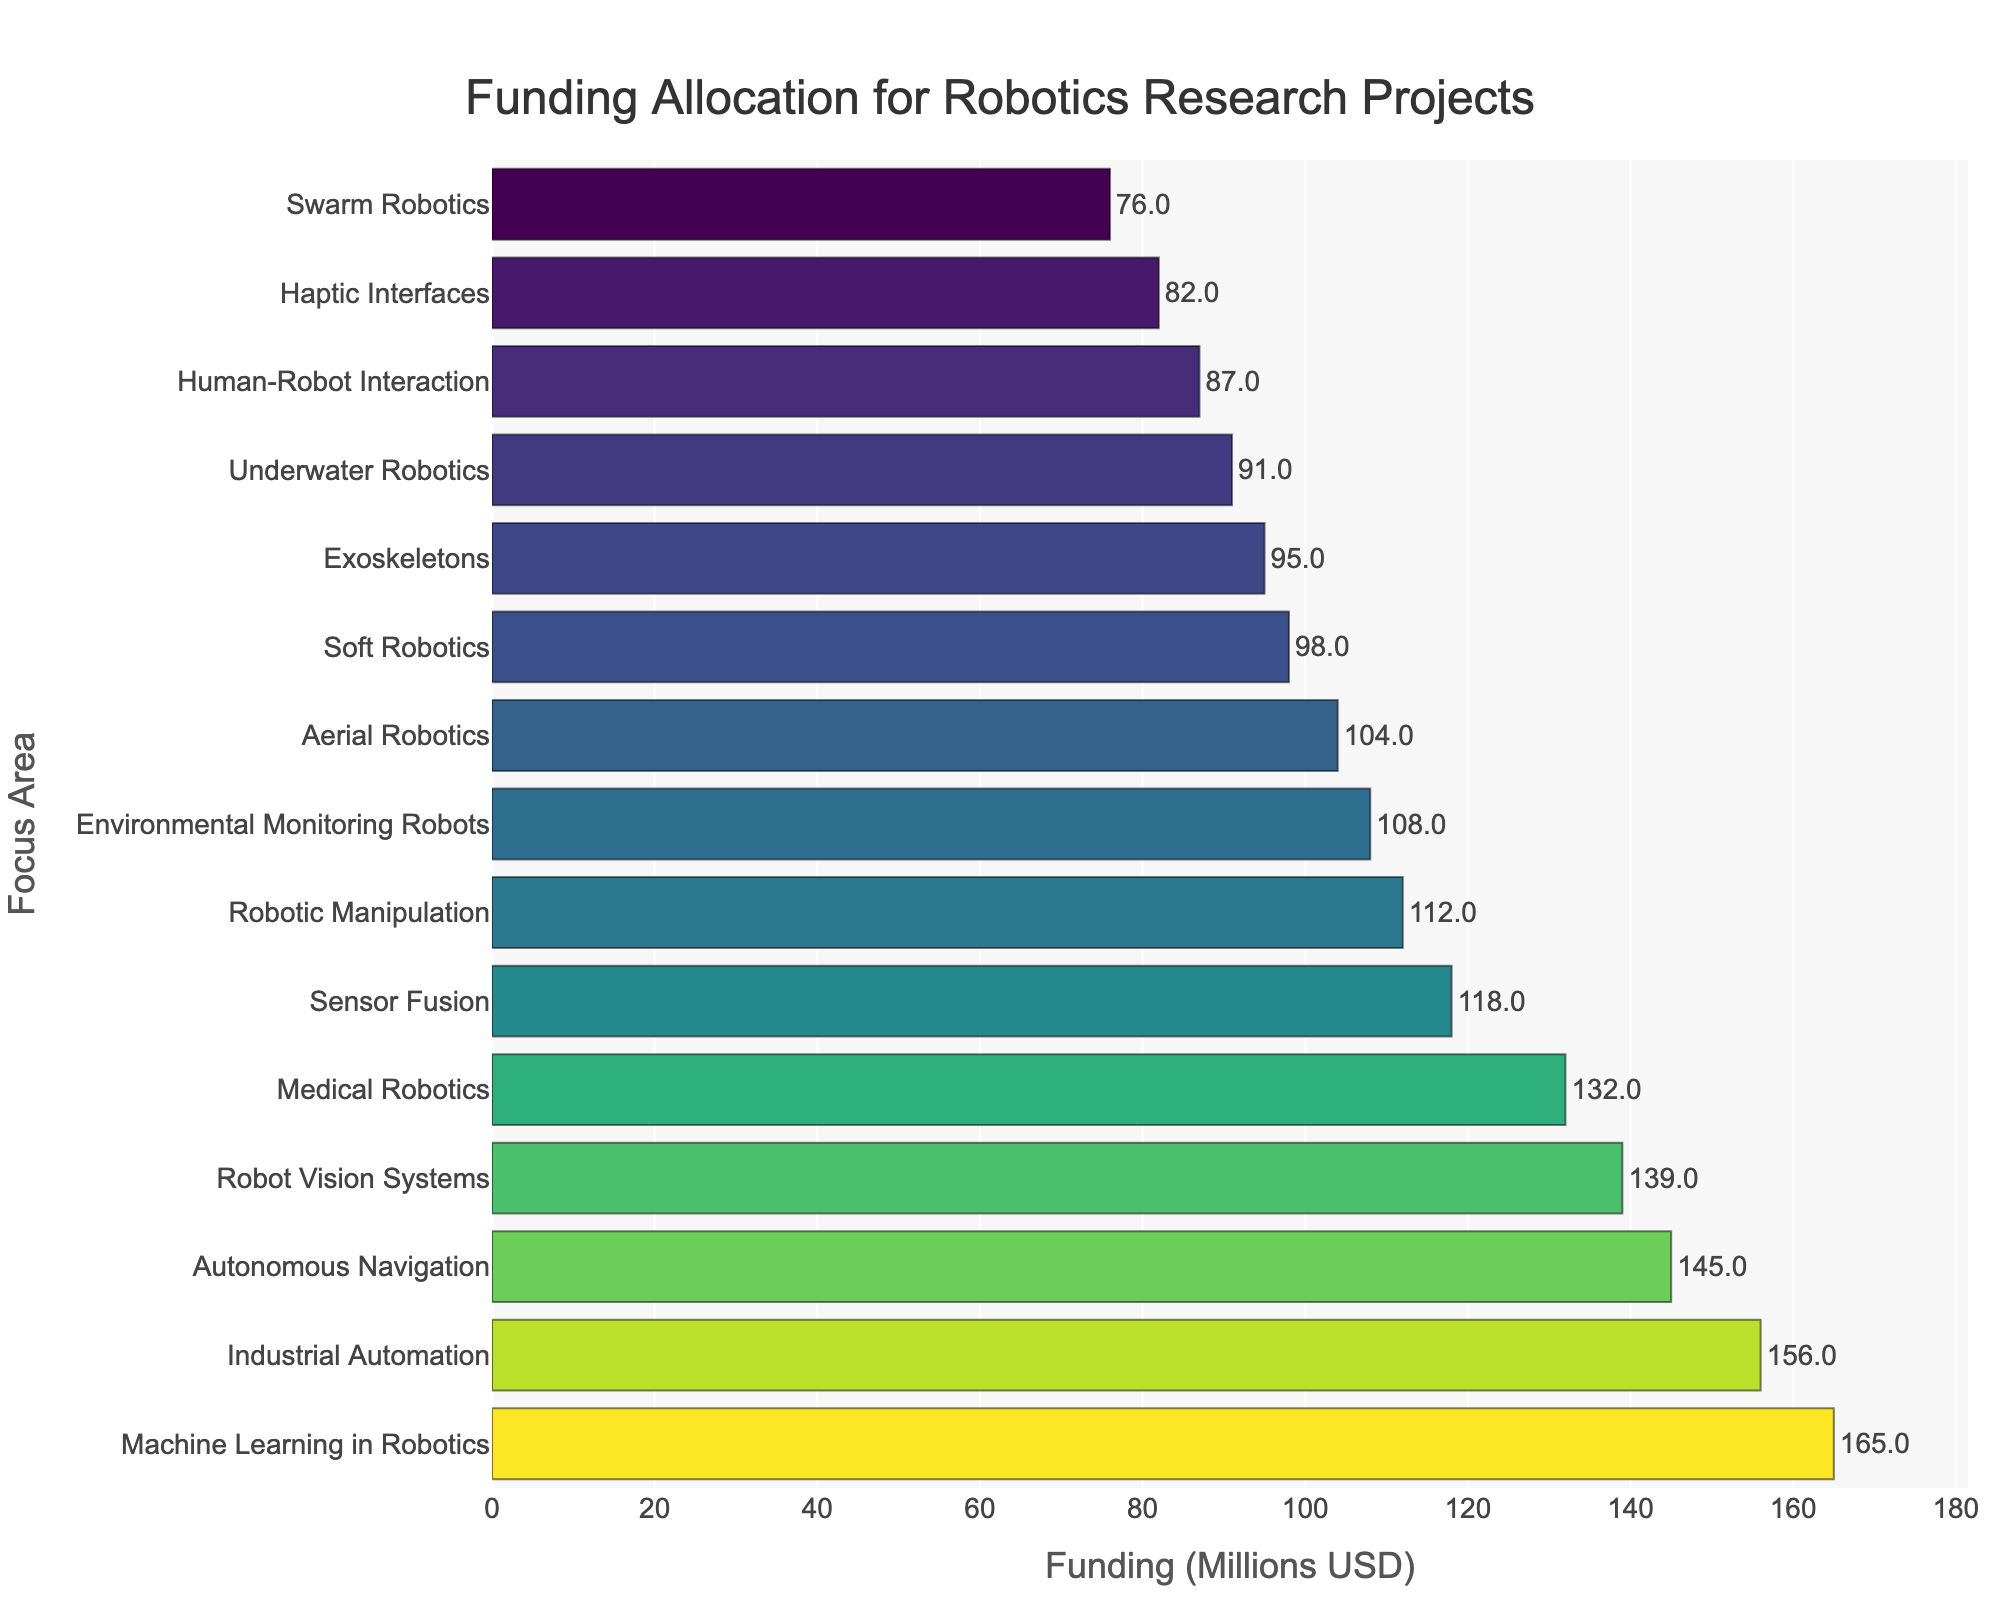Which focus area received the most funding? The bar representing "Machine Learning in Robotics" is the longest on the chart, indicating it received the most funding.
Answer: Machine Learning in Robotics How much more funding did Autonomous Navigation receive compared to Human-Robot Interaction? Find the funding for both areas: Autonomous Navigation (145M USD) and Human-Robot Interaction (87M USD). Subtract the latter from the former: 145 - 87 = 58.
Answer: 58 million USD Which focus areas received less than 100 million USD in funding? Look for the bars with lengths corresponding to funding amounts below 100 million USD: Soft Robotics (98M), Human-Robot Interaction (87M), Swarm Robotics (76M), Haptic Interfaces (82M), Exoskeletons (95M), and Underwater Robotics (91M).
Answer: Soft Robotics, Human-Robot Interaction, Swarm Robotics, Haptic Interfaces, Exoskeletons, Underwater Robotics What is the total funding allocated to Aerial Robotics and Underwater Robotics? Sum the funding for Aerial Robotics (104M USD) and Underwater Robotics (91M USD): 104 + 91 = 195.
Answer: 195 million USD How does the funding for Industrial Automation compare to that for Environmental Monitoring Robots? Compare the funding amounts: Industrial Automation (156M USD) and Environmental Monitoring Robots (108M USD). Industrial Automation received more funding.
Answer: Industrial Automation received more funding What is the median funding amount among all the focus areas? Arrange the funding amounts in ascending order and locate the central value. Ordered amounts: 76, 82, 87, 91, 95, 98, 104, 108, 112, 118, 132, 139, 145, 156, 165. The median is the 8th value, which is 108M USD.
Answer: 108 million USD How much funding did the top three focus areas receive in total? Identify the top three focus areas: Machine Learning in Robotics (165M USD), Industrial Automation (156M USD), and Autonomous Navigation (145M USD). Sum these amounts: 165 + 156 + 145 = 466.
Answer: 466 million USD Which focus area has the shortest bar, and what is the funding amount for it? Locate the shortest bar in the chart corresponding to Swarm Robotics, indicating the funding amount is 76 million USD.
Answer: Swarm Robotics, 76 million USD 